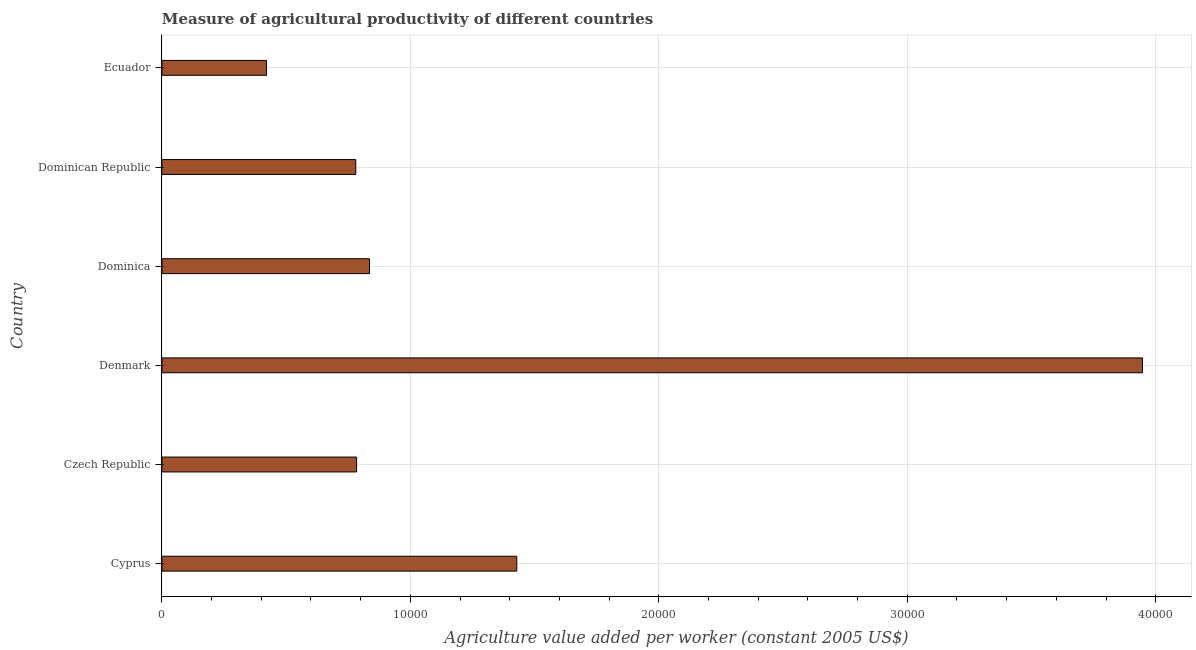What is the title of the graph?
Your answer should be very brief. Measure of agricultural productivity of different countries. What is the label or title of the X-axis?
Your answer should be very brief. Agriculture value added per worker (constant 2005 US$). What is the agriculture value added per worker in Denmark?
Your answer should be very brief. 3.95e+04. Across all countries, what is the maximum agriculture value added per worker?
Make the answer very short. 3.95e+04. Across all countries, what is the minimum agriculture value added per worker?
Offer a very short reply. 4209.62. In which country was the agriculture value added per worker maximum?
Provide a succinct answer. Denmark. In which country was the agriculture value added per worker minimum?
Offer a very short reply. Ecuador. What is the sum of the agriculture value added per worker?
Ensure brevity in your answer.  8.20e+04. What is the difference between the agriculture value added per worker in Cyprus and Denmark?
Make the answer very short. -2.52e+04. What is the average agriculture value added per worker per country?
Give a very brief answer. 1.37e+04. What is the median agriculture value added per worker?
Ensure brevity in your answer.  8095.66. In how many countries, is the agriculture value added per worker greater than 28000 US$?
Give a very brief answer. 1. What is the ratio of the agriculture value added per worker in Cyprus to that in Denmark?
Keep it short and to the point. 0.36. Is the agriculture value added per worker in Cyprus less than that in Dominican Republic?
Offer a terse response. No. Is the difference between the agriculture value added per worker in Czech Republic and Dominica greater than the difference between any two countries?
Your answer should be compact. No. What is the difference between the highest and the second highest agriculture value added per worker?
Offer a very short reply. 2.52e+04. What is the difference between the highest and the lowest agriculture value added per worker?
Make the answer very short. 3.53e+04. How many bars are there?
Your answer should be very brief. 6. Are all the bars in the graph horizontal?
Your response must be concise. Yes. What is the difference between two consecutive major ticks on the X-axis?
Offer a very short reply. 10000. Are the values on the major ticks of X-axis written in scientific E-notation?
Your response must be concise. No. What is the Agriculture value added per worker (constant 2005 US$) of Cyprus?
Offer a terse response. 1.43e+04. What is the Agriculture value added per worker (constant 2005 US$) in Czech Republic?
Your response must be concise. 7836.37. What is the Agriculture value added per worker (constant 2005 US$) in Denmark?
Offer a very short reply. 3.95e+04. What is the Agriculture value added per worker (constant 2005 US$) of Dominica?
Your answer should be compact. 8354.94. What is the Agriculture value added per worker (constant 2005 US$) of Dominican Republic?
Offer a terse response. 7802.84. What is the Agriculture value added per worker (constant 2005 US$) of Ecuador?
Offer a very short reply. 4209.62. What is the difference between the Agriculture value added per worker (constant 2005 US$) in Cyprus and Czech Republic?
Offer a very short reply. 6447.01. What is the difference between the Agriculture value added per worker (constant 2005 US$) in Cyprus and Denmark?
Your response must be concise. -2.52e+04. What is the difference between the Agriculture value added per worker (constant 2005 US$) in Cyprus and Dominica?
Keep it short and to the point. 5928.45. What is the difference between the Agriculture value added per worker (constant 2005 US$) in Cyprus and Dominican Republic?
Make the answer very short. 6480.54. What is the difference between the Agriculture value added per worker (constant 2005 US$) in Cyprus and Ecuador?
Provide a succinct answer. 1.01e+04. What is the difference between the Agriculture value added per worker (constant 2005 US$) in Czech Republic and Denmark?
Ensure brevity in your answer.  -3.16e+04. What is the difference between the Agriculture value added per worker (constant 2005 US$) in Czech Republic and Dominica?
Ensure brevity in your answer.  -518.56. What is the difference between the Agriculture value added per worker (constant 2005 US$) in Czech Republic and Dominican Republic?
Offer a terse response. 33.53. What is the difference between the Agriculture value added per worker (constant 2005 US$) in Czech Republic and Ecuador?
Your answer should be compact. 3626.75. What is the difference between the Agriculture value added per worker (constant 2005 US$) in Denmark and Dominica?
Provide a succinct answer. 3.11e+04. What is the difference between the Agriculture value added per worker (constant 2005 US$) in Denmark and Dominican Republic?
Make the answer very short. 3.17e+04. What is the difference between the Agriculture value added per worker (constant 2005 US$) in Denmark and Ecuador?
Keep it short and to the point. 3.53e+04. What is the difference between the Agriculture value added per worker (constant 2005 US$) in Dominica and Dominican Republic?
Your response must be concise. 552.09. What is the difference between the Agriculture value added per worker (constant 2005 US$) in Dominica and Ecuador?
Your answer should be compact. 4145.32. What is the difference between the Agriculture value added per worker (constant 2005 US$) in Dominican Republic and Ecuador?
Your answer should be compact. 3593.22. What is the ratio of the Agriculture value added per worker (constant 2005 US$) in Cyprus to that in Czech Republic?
Offer a very short reply. 1.82. What is the ratio of the Agriculture value added per worker (constant 2005 US$) in Cyprus to that in Denmark?
Offer a terse response. 0.36. What is the ratio of the Agriculture value added per worker (constant 2005 US$) in Cyprus to that in Dominica?
Keep it short and to the point. 1.71. What is the ratio of the Agriculture value added per worker (constant 2005 US$) in Cyprus to that in Dominican Republic?
Your answer should be compact. 1.83. What is the ratio of the Agriculture value added per worker (constant 2005 US$) in Cyprus to that in Ecuador?
Provide a succinct answer. 3.39. What is the ratio of the Agriculture value added per worker (constant 2005 US$) in Czech Republic to that in Denmark?
Your response must be concise. 0.2. What is the ratio of the Agriculture value added per worker (constant 2005 US$) in Czech Republic to that in Dominica?
Make the answer very short. 0.94. What is the ratio of the Agriculture value added per worker (constant 2005 US$) in Czech Republic to that in Dominican Republic?
Keep it short and to the point. 1. What is the ratio of the Agriculture value added per worker (constant 2005 US$) in Czech Republic to that in Ecuador?
Provide a succinct answer. 1.86. What is the ratio of the Agriculture value added per worker (constant 2005 US$) in Denmark to that in Dominica?
Your answer should be very brief. 4.72. What is the ratio of the Agriculture value added per worker (constant 2005 US$) in Denmark to that in Dominican Republic?
Provide a short and direct response. 5.06. What is the ratio of the Agriculture value added per worker (constant 2005 US$) in Denmark to that in Ecuador?
Make the answer very short. 9.38. What is the ratio of the Agriculture value added per worker (constant 2005 US$) in Dominica to that in Dominican Republic?
Provide a succinct answer. 1.07. What is the ratio of the Agriculture value added per worker (constant 2005 US$) in Dominica to that in Ecuador?
Your answer should be compact. 1.99. What is the ratio of the Agriculture value added per worker (constant 2005 US$) in Dominican Republic to that in Ecuador?
Your answer should be compact. 1.85. 